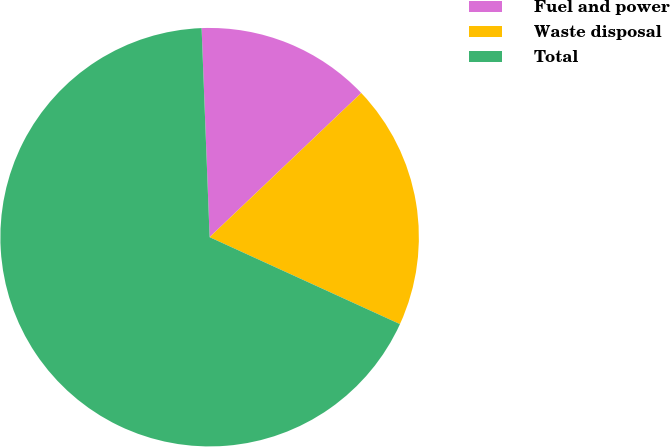Convert chart to OTSL. <chart><loc_0><loc_0><loc_500><loc_500><pie_chart><fcel>Fuel and power<fcel>Waste disposal<fcel>Total<nl><fcel>13.51%<fcel>18.92%<fcel>67.57%<nl></chart> 